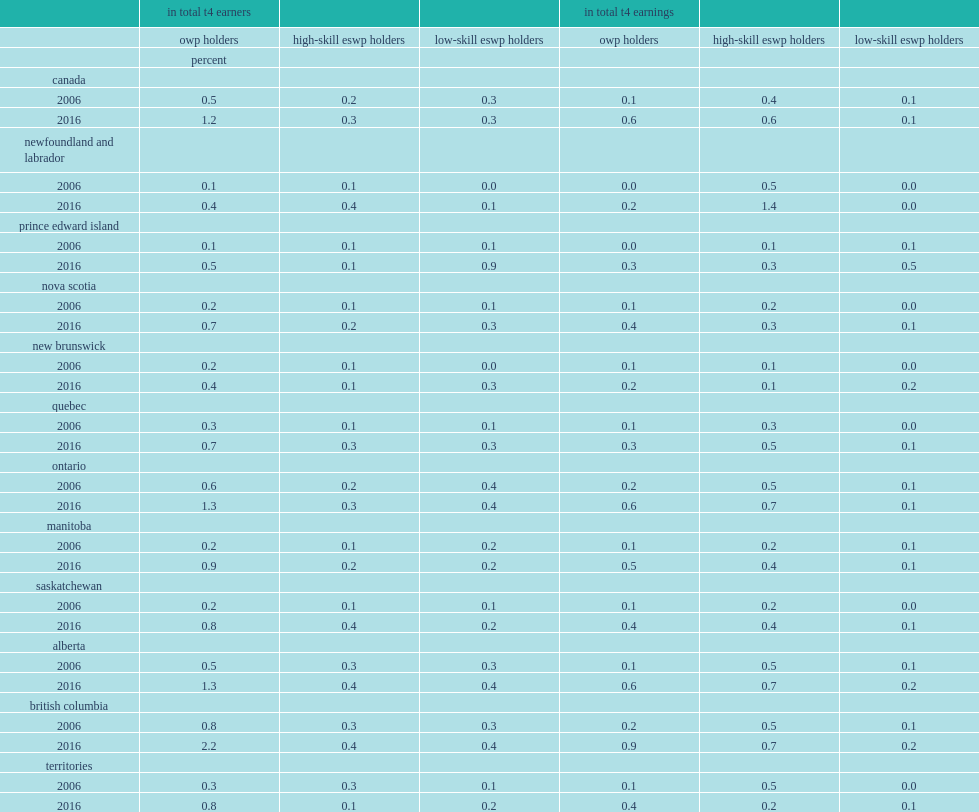Parse the table in full. {'header': ['', 'in total t4 earners', '', '', 'in total t4 earnings', '', ''], 'rows': [['', 'owp holders', 'high-skill eswp holders', 'low-skill eswp holders', 'owp holders', 'high-skill eswp holders', 'low-skill eswp holders'], ['', 'percent', '', '', '', '', ''], ['canada', '', '', '', '', '', ''], ['2006', '0.5', '0.2', '0.3', '0.1', '0.4', '0.1'], ['2016', '1.2', '0.3', '0.3', '0.6', '0.6', '0.1'], ['newfoundland and labrador', '', '', '', '', '', ''], ['2006', '0.1', '0.1', '0.0', '0.0', '0.5', '0.0'], ['2016', '0.4', '0.4', '0.1', '0.2', '1.4', '0.0'], ['prince edward island', '', '', '', '', '', ''], ['2006', '0.1', '0.1', '0.1', '0.0', '0.1', '0.1'], ['2016', '0.5', '0.1', '0.9', '0.3', '0.3', '0.5'], ['nova scotia', '', '', '', '', '', ''], ['2006', '0.2', '0.1', '0.1', '0.1', '0.2', '0.0'], ['2016', '0.7', '0.2', '0.3', '0.4', '0.3', '0.1'], ['new brunswick', '', '', '', '', '', ''], ['2006', '0.2', '0.1', '0.0', '0.1', '0.1', '0.0'], ['2016', '0.4', '0.1', '0.3', '0.2', '0.1', '0.2'], ['quebec', '', '', '', '', '', ''], ['2006', '0.3', '0.1', '0.1', '0.1', '0.3', '0.0'], ['2016', '0.7', '0.3', '0.3', '0.3', '0.5', '0.1'], ['ontario', '', '', '', '', '', ''], ['2006', '0.6', '0.2', '0.4', '0.2', '0.5', '0.1'], ['2016', '1.3', '0.3', '0.4', '0.6', '0.7', '0.1'], ['manitoba', '', '', '', '', '', ''], ['2006', '0.2', '0.1', '0.2', '0.1', '0.2', '0.1'], ['2016', '0.9', '0.2', '0.2', '0.5', '0.4', '0.1'], ['saskatchewan', '', '', '', '', '', ''], ['2006', '0.2', '0.1', '0.1', '0.1', '0.2', '0.0'], ['2016', '0.8', '0.4', '0.2', '0.4', '0.4', '0.1'], ['alberta', '', '', '', '', '', ''], ['2006', '0.5', '0.3', '0.3', '0.1', '0.5', '0.1'], ['2016', '1.3', '0.4', '0.4', '0.6', '0.7', '0.2'], ['british columbia', '', '', '', '', '', ''], ['2006', '0.8', '0.3', '0.3', '0.2', '0.5', '0.1'], ['2016', '2.2', '0.4', '0.4', '0.9', '0.7', '0.2'], ['territories', '', '', '', '', '', ''], ['2006', '0.3', '0.3', '0.1', '0.1', '0.5', '0.0'], ['2016', '0.8', '0.1', '0.2', '0.4', '0.2', '0.1']]} What percentage of total t4 earners did owp holders account for in canada in 2016? 1.2. What percentage of total t4 earners did owp holders account for in canada in 2006? 0.5. Which province in canada used more owp and eswp tfws than the national average across regions? British columbia. What percentage of the total t4 earners did owp holders account for in british columbia in 2016? 2.2. What percentage of the total t4 earnings did owp holders account for in british columbia in 2016? 0.9. What percentage of the total t4 earners did eswp holders account for in british columbia in 2016? 0.8. What percentage of the total t4 earnings did eswp holders account for in british columbia in 2016? 0.9. 